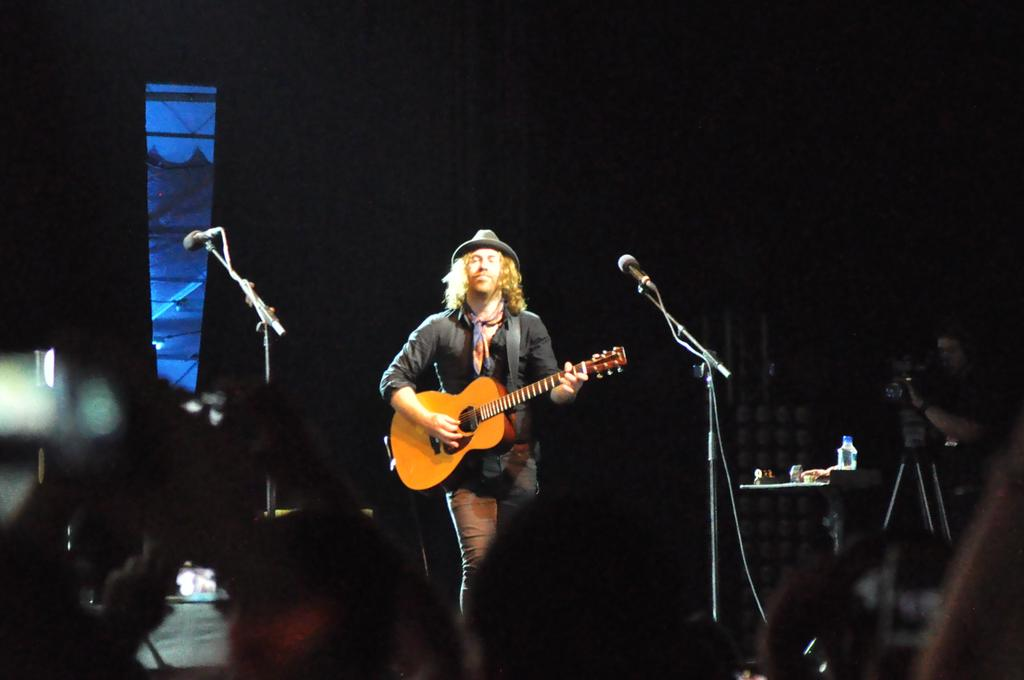What is the main subject of the image? The main subject of the image is a man. What is the man doing in the image? The man is standing and playing the guitar. What is the man wearing on his head? The man is wearing a hat. What equipment is present in the image? There are microphones and stands in the image. What can be observed about the background of the image? The background of the image is dark. What type of mark is visible on the man's guitar in the image? There is no mention of a mark on the guitar in the image. --- Facts: 1. There is a car in the image. 2. The car is red. 3. The car has four wheels. 4. The car has a sunroof. 5. There are people standing near the car. 6. The people are holding signs. Absurd Topics: cat Conversation: What is the main subject in the image? The main subject in the image is a car. What color is the car? The car is red. How many wheels does the car have? The car has four wheels. What special feature does the car have? The car has a sunroof. Are there any people in the image? Yes, there are people standing near the car. What are the people doing in the image? The people are holding signs. Reasoning: Let's think step by step in order to produce the conversation. We start by identifying the main subject of the image, which is the car. Next, we describe specific features of the car, such as its color and the presence of a sunroof. Then, we observe the actions of the people in the image, noting that they are holding signs. Finally, we ensure that the language is simple and clear. Absurd Question/Answer: Can you see a cat sitting on the hood of the car in the image? No, there is no cat sitting on the hood of the car in the image. 